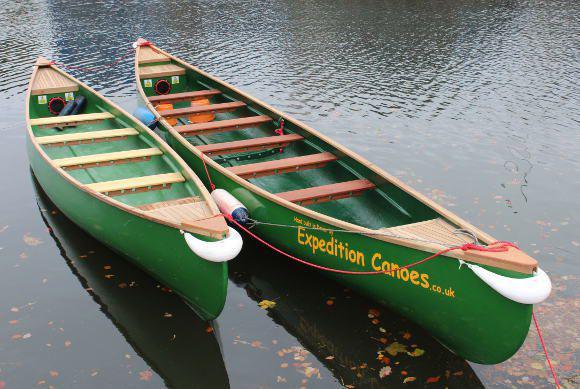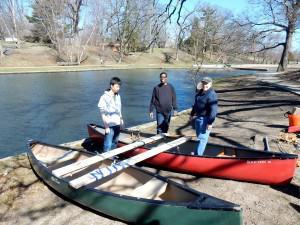The first image is the image on the left, the second image is the image on the right. Evaluate the accuracy of this statement regarding the images: "In one picture the canoes are in the water and in the other picture the canoes are not in the water.". Is it true? Answer yes or no. Yes. The first image is the image on the left, the second image is the image on the right. Examine the images to the left and right. Is the description "There is at least one human standing inside a boat while the boat is in the water." accurate? Answer yes or no. No. The first image is the image on the left, the second image is the image on the right. Examine the images to the left and right. Is the description "There is three humans in the right image." accurate? Answer yes or no. Yes. The first image is the image on the left, the second image is the image on the right. Considering the images on both sides, is "In one image, two green canoes are side by side" valid? Answer yes or no. Yes. 